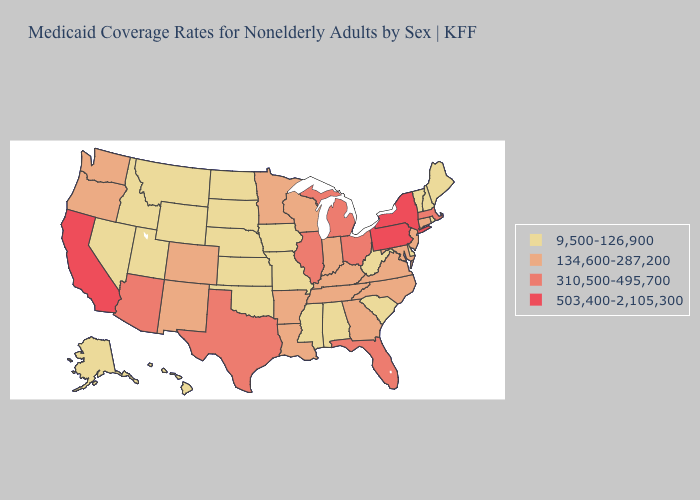What is the highest value in states that border Tennessee?
Concise answer only. 134,600-287,200. Name the states that have a value in the range 9,500-126,900?
Give a very brief answer. Alabama, Alaska, Delaware, Hawaii, Idaho, Iowa, Kansas, Maine, Mississippi, Missouri, Montana, Nebraska, Nevada, New Hampshire, North Dakota, Oklahoma, Rhode Island, South Carolina, South Dakota, Utah, Vermont, West Virginia, Wyoming. Name the states that have a value in the range 503,400-2,105,300?
Give a very brief answer. California, New York, Pennsylvania. Which states hav the highest value in the Northeast?
Be succinct. New York, Pennsylvania. What is the highest value in the USA?
Short answer required. 503,400-2,105,300. Does the first symbol in the legend represent the smallest category?
Short answer required. Yes. What is the value of Florida?
Answer briefly. 310,500-495,700. Is the legend a continuous bar?
Write a very short answer. No. What is the value of Nevada?
Short answer required. 9,500-126,900. Is the legend a continuous bar?
Answer briefly. No. What is the lowest value in states that border Iowa?
Answer briefly. 9,500-126,900. Which states have the highest value in the USA?
Quick response, please. California, New York, Pennsylvania. Does Wyoming have the lowest value in the USA?
Give a very brief answer. Yes. Is the legend a continuous bar?
Quick response, please. No. 